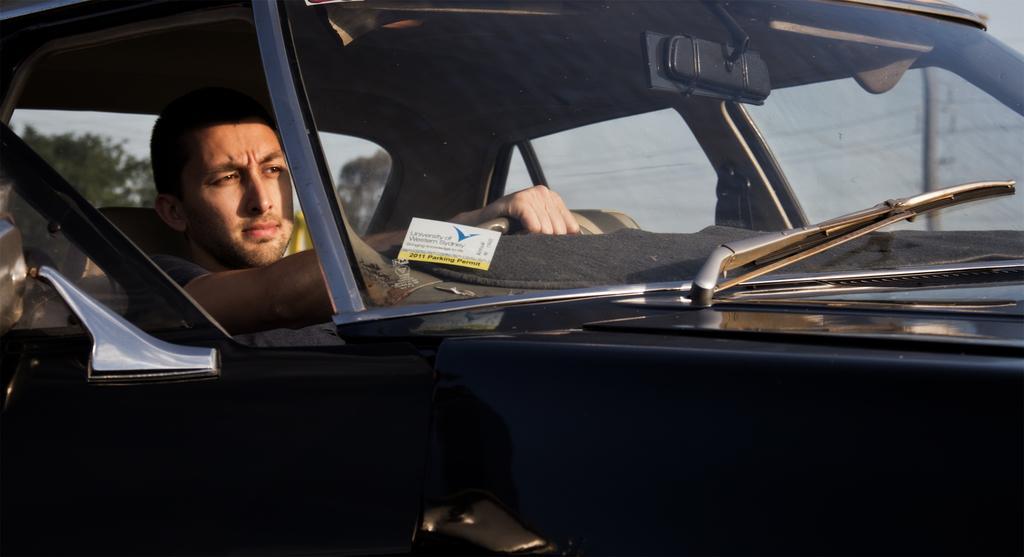Could you give a brief overview of what you see in this image? This image consists of a car and a person is in that car. He is driving. There is a wiper, mirror on that car. The car is in black color. 